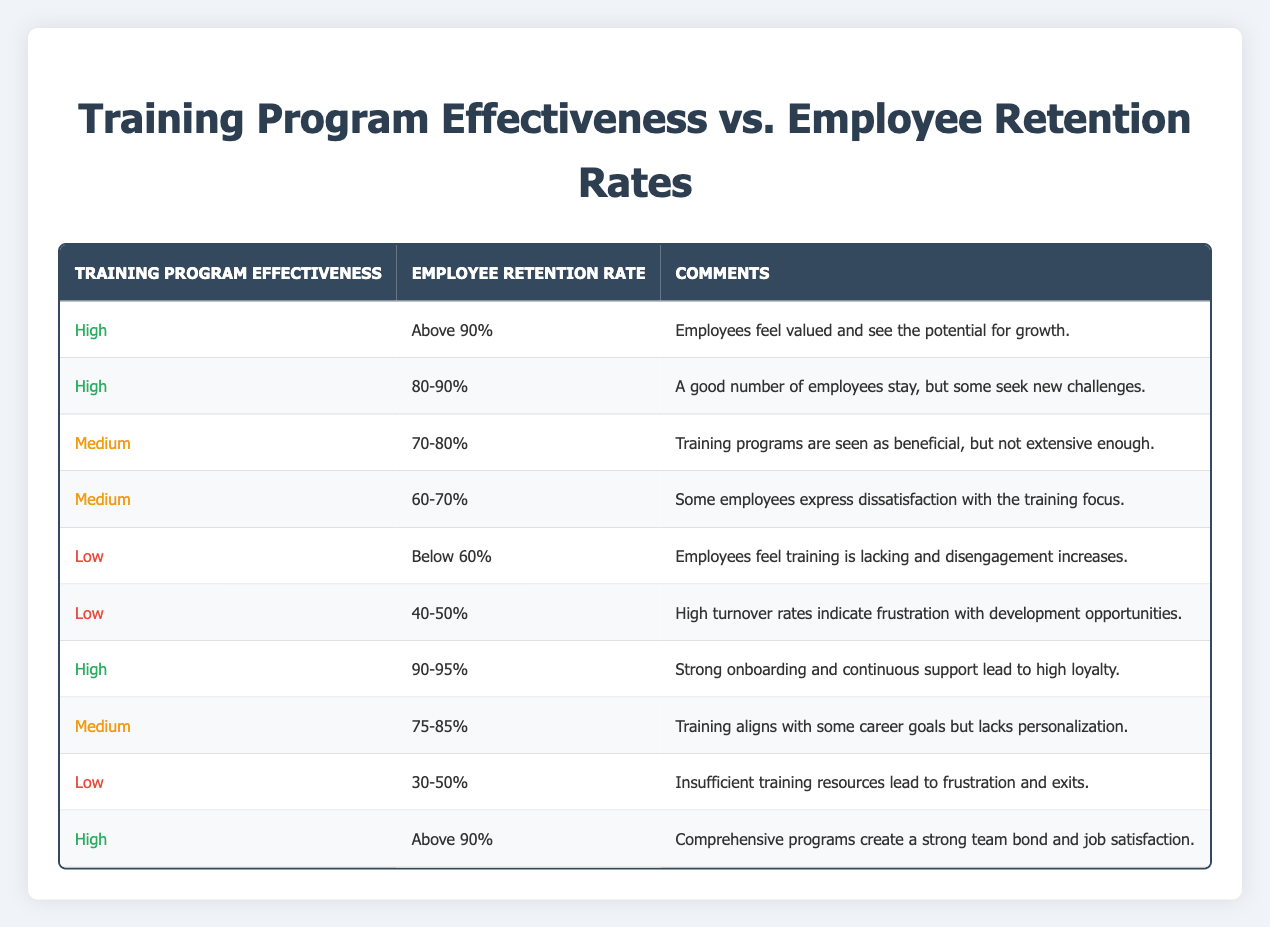What is the most common employee retention rate associated with high training program effectiveness? By looking at the rows where "Training Program Effectiveness" is "High", the employee retention rates listed are "Above 90%", "80-90%", and "90-95%". However, "Above 90%" is mentioned twice, indicating it is the most common rate for high effectiveness.
Answer: Above 90% What comment is associated with a medium training program effectiveness and an employee retention rate of 70-80%? The row that matches "Medium" for "Training Program Effectiveness" and "70-80%" for "Employee Retention Rate" has the comment "Training programs are seen as beneficial, but not extensive enough."
Answer: Training programs are seen as beneficial, but not extensive enough True or False: Low training program effectiveness typically results in retention rates above 60%. Examining the rows with "Low" for "Training Program Effectiveness", we see that the highest retention rate is "40-50%" and the lowest is "Below 60%", confirming that all rates are below 60%.
Answer: False What are the employee retention rate categories associated with high training program effectiveness? Reviewing all entries with "High" for "Training Program Effectiveness", the retention rates are "Above 90%", "80-90%", and "90-95%". These are the three categories linked to high effectiveness.
Answer: Above 90%, 80-90%, and 90-95% Calculate the average retention rate for medium training program effectiveness. The retention rates for "Medium" effectiveness are "70-80%", "60-70%", and "75-85%". Converting these ranges to numerical formats: 
- 70-80% is averaged as 75%
- 60-70% is averaged as 65%
- 75-85% is averaged as 80%
To find the average: (75 + 65 + 80) / 3 = 220 / 3 = approximately 73.33%.
Answer: Approximately 73.33% Which retention rate has the highest associated comments about employee satisfaction? The highest retention rates associated with "High" training program effectiveness in the comments include "Employees feel valued and see the potential for growth" and "Comprehensive programs create a strong team bond and job satisfaction." Both comments emphasize positivity about employee satisfaction.
Answer: Above 90% What percentage range is observed for employee retention when the training program effectiveness is low? For "Low" training program effectiveness, the retention rates listed are "Below 60%", "40-50%", and "30-50%", confirming that they all fall below 60%.
Answer: Below 60% True or False: The data indicates that effective training programs are linked to lower turnover rates. Reviewing the effectiveness and retention data, "High" effectiveness consistently correlates with higher retention rates, while "Low" effectiveness aligns with lower retention rates, confirming that effective training reduces turnover.
Answer: True 